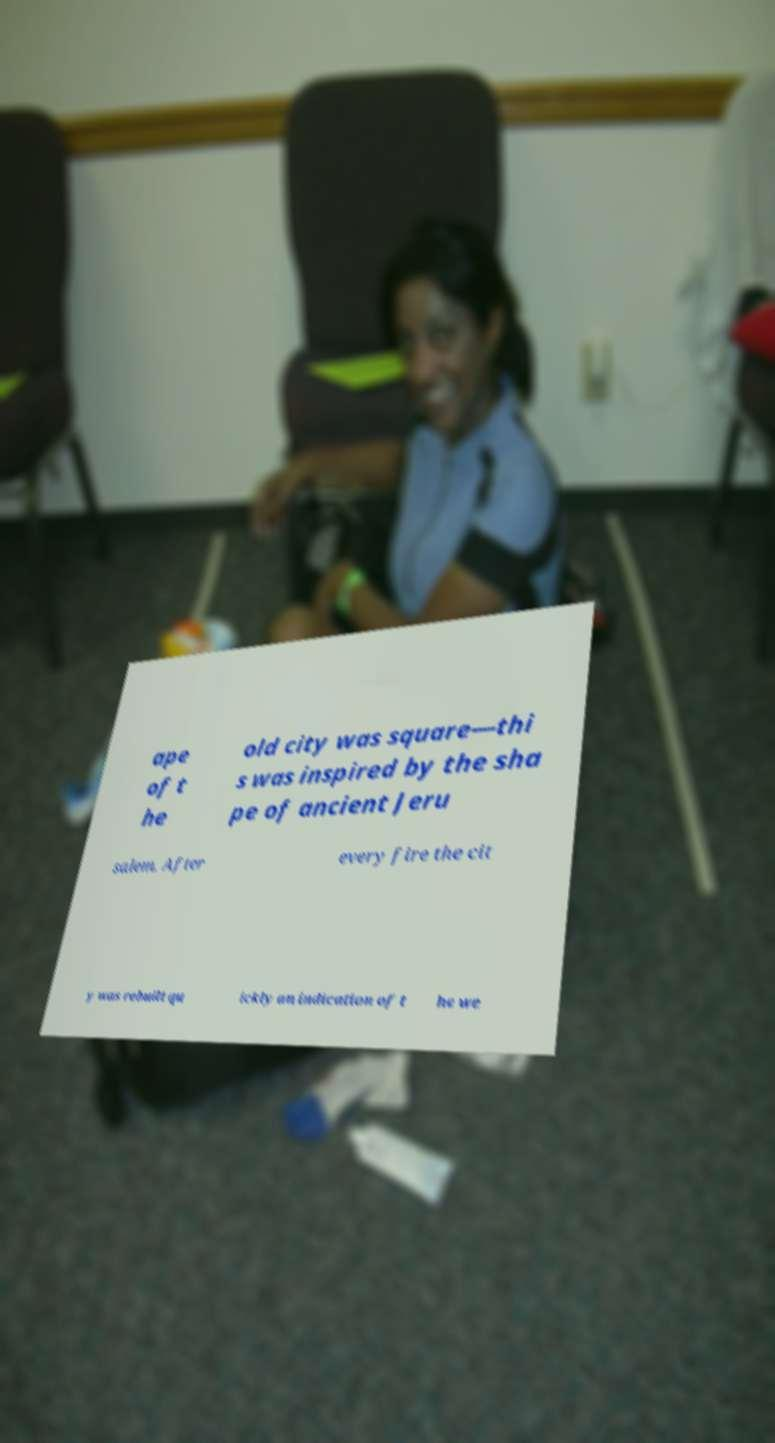Could you extract and type out the text from this image? ape of t he old city was square—thi s was inspired by the sha pe of ancient Jeru salem. After every fire the cit y was rebuilt qu ickly an indication of t he we 